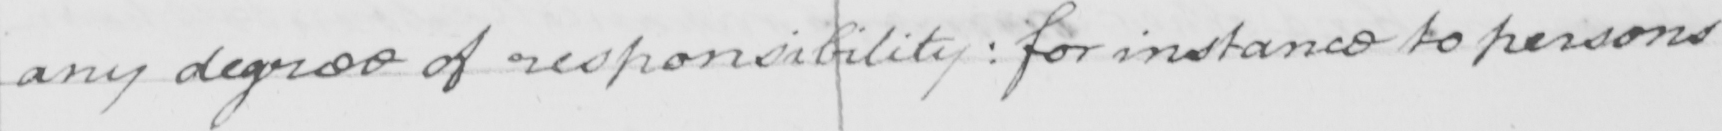Can you tell me what this handwritten text says? any degree of responsibility :  for instance to persons 